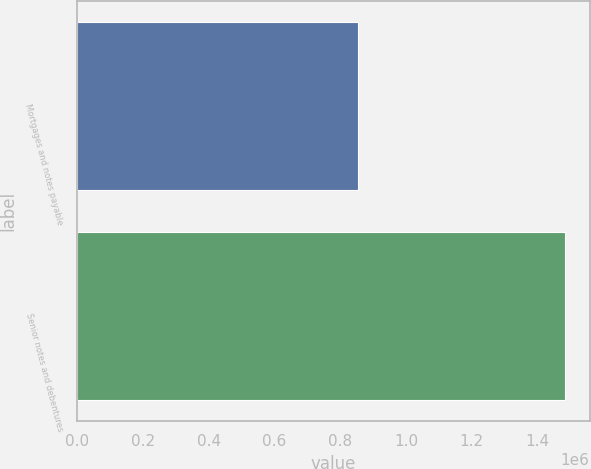<chart> <loc_0><loc_0><loc_500><loc_500><bar_chart><fcel>Mortgages and notes payable<fcel>Senior notes and debentures<nl><fcel>854217<fcel>1.48381e+06<nl></chart> 